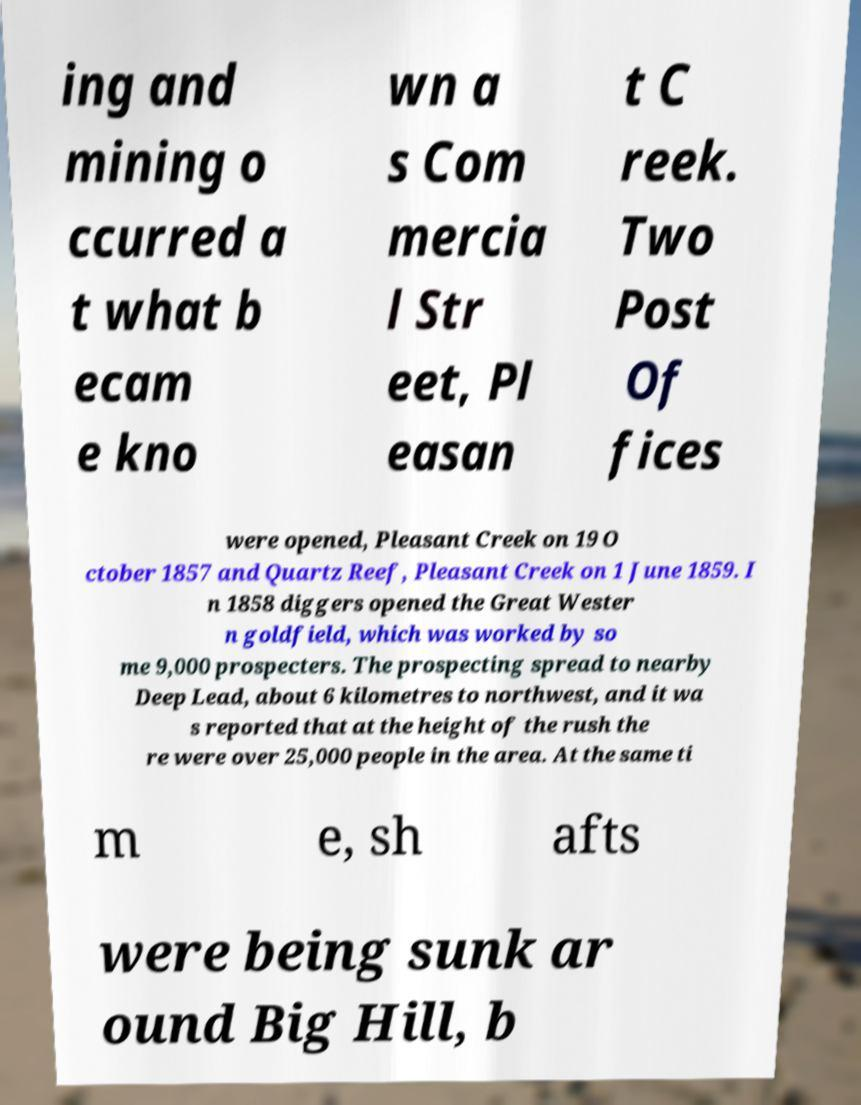Please read and relay the text visible in this image. What does it say? ing and mining o ccurred a t what b ecam e kno wn a s Com mercia l Str eet, Pl easan t C reek. Two Post Of fices were opened, Pleasant Creek on 19 O ctober 1857 and Quartz Reef, Pleasant Creek on 1 June 1859. I n 1858 diggers opened the Great Wester n goldfield, which was worked by so me 9,000 prospecters. The prospecting spread to nearby Deep Lead, about 6 kilometres to northwest, and it wa s reported that at the height of the rush the re were over 25,000 people in the area. At the same ti m e, sh afts were being sunk ar ound Big Hill, b 